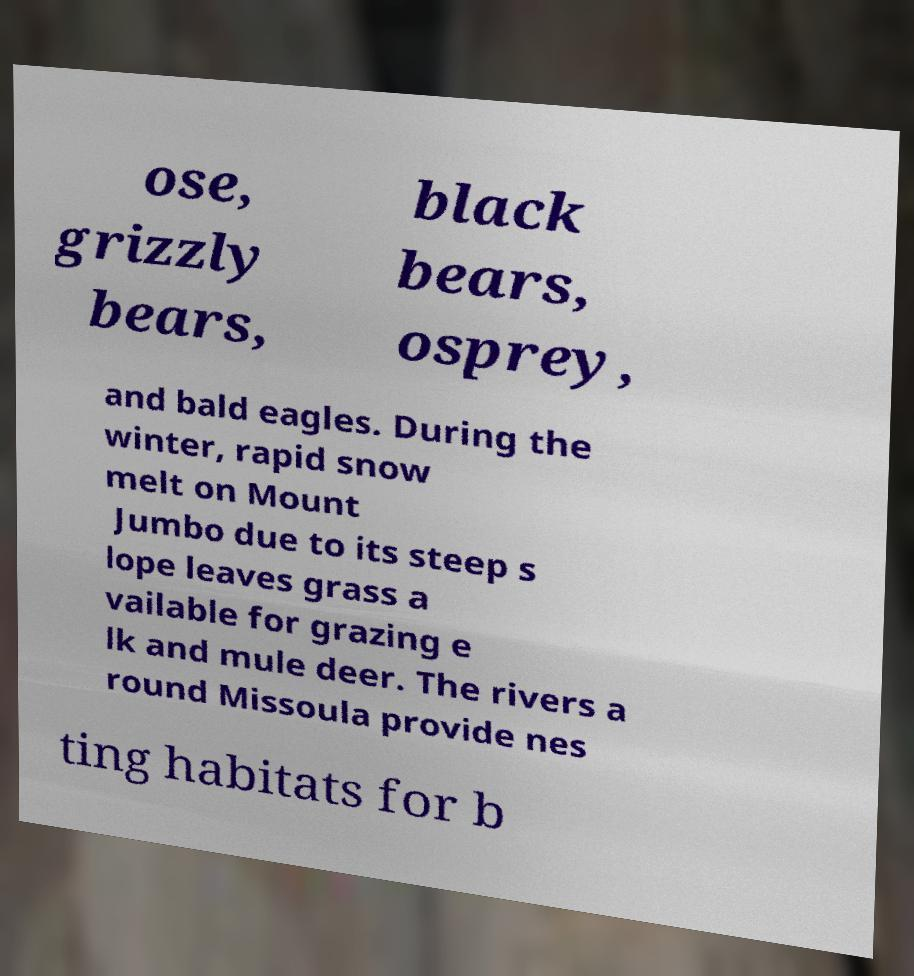For documentation purposes, I need the text within this image transcribed. Could you provide that? ose, grizzly bears, black bears, osprey, and bald eagles. During the winter, rapid snow melt on Mount Jumbo due to its steep s lope leaves grass a vailable for grazing e lk and mule deer. The rivers a round Missoula provide nes ting habitats for b 